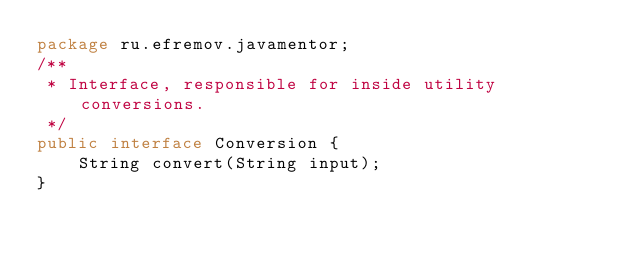<code> <loc_0><loc_0><loc_500><loc_500><_Java_>package ru.efremov.javamentor;
/**
 * Interface, responsible for inside utility conversions.
 */
public interface Conversion {
    String convert(String input);
}
</code> 